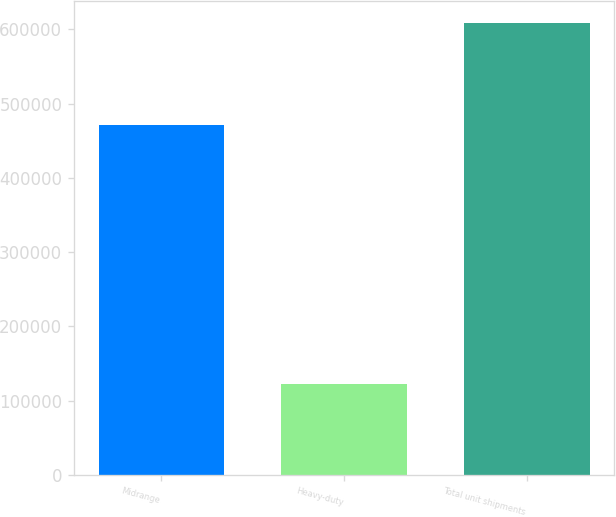Convert chart. <chart><loc_0><loc_0><loc_500><loc_500><bar_chart><fcel>Midrange<fcel>Heavy-duty<fcel>Total unit shipments<nl><fcel>471200<fcel>122100<fcel>608100<nl></chart> 